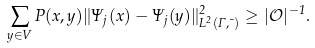Convert formula to latex. <formula><loc_0><loc_0><loc_500><loc_500>\sum _ { y \in V } P ( x , y ) \| \Psi _ { j } ( x ) - \Psi _ { j } ( y ) \| _ { L ^ { 2 } ( \Gamma , \mu ) } ^ { 2 } \geq | \mathcal { O } | ^ { - 1 } .</formula> 